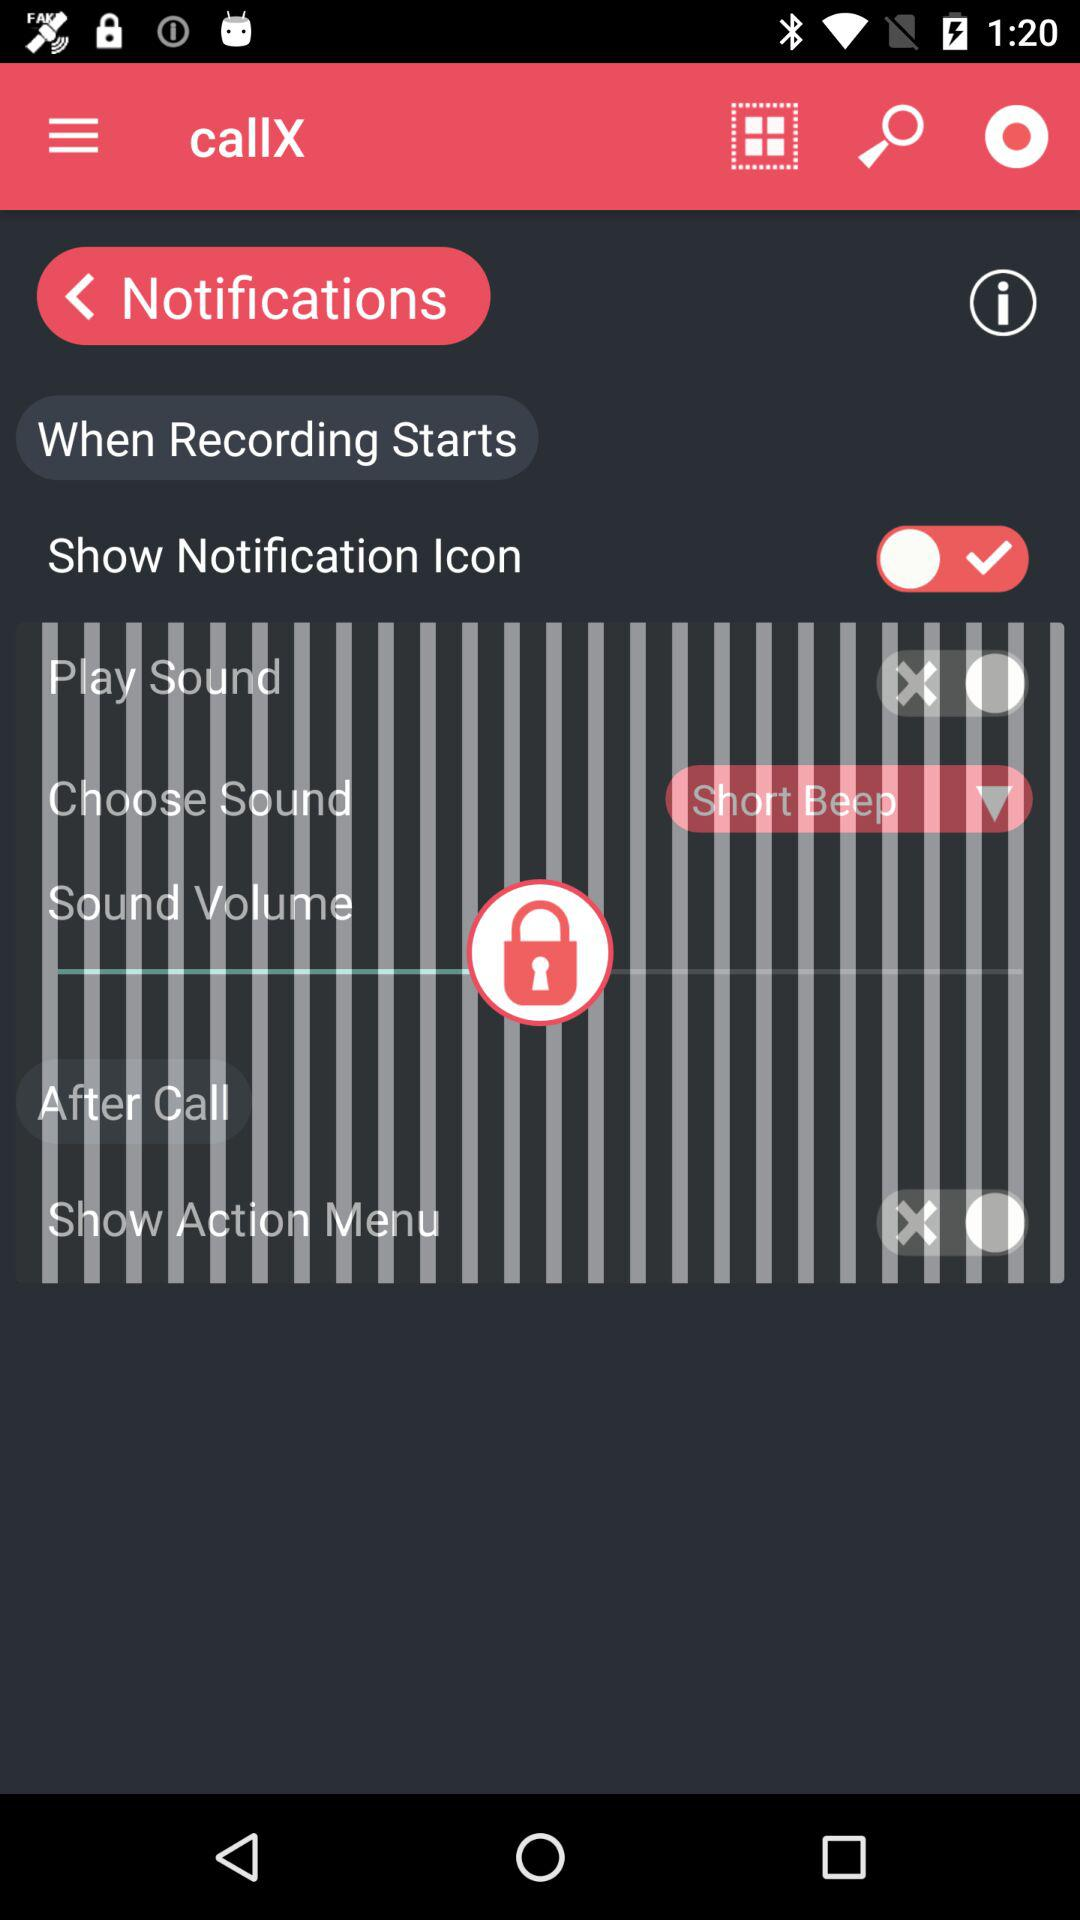What is the application name? The application name is "callX". 